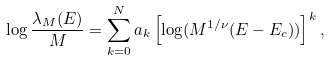<formula> <loc_0><loc_0><loc_500><loc_500>\log \frac { \lambda _ { M } ( E ) } { M } = \sum _ { k = 0 } ^ { N } a _ { k } \left [ \log ( M ^ { 1 / \nu } ( E - E _ { c } ) ) \right ] ^ { k } ,</formula> 